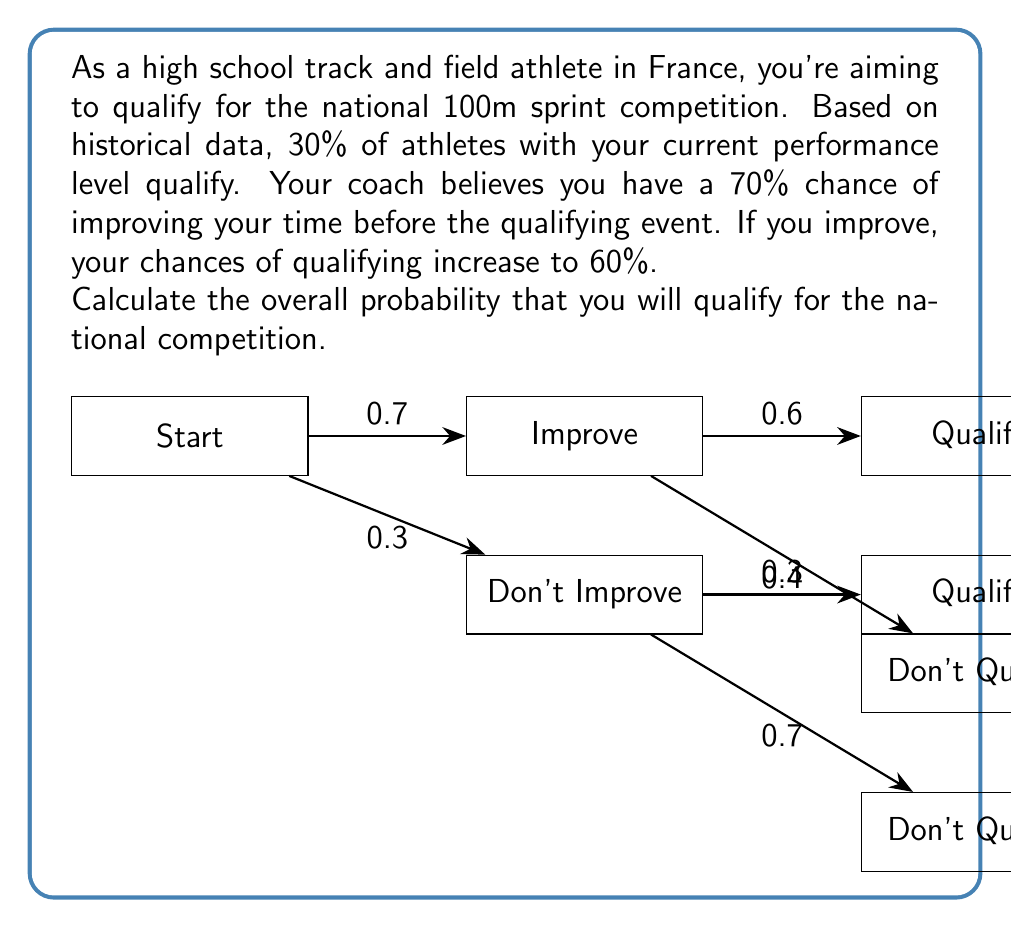Can you answer this question? Let's approach this problem using the law of total probability and Bayes' theorem:

1) Define events:
   A: Qualify for the national competition
   B: Improve your time

2) Given probabilities:
   P(B) = 0.7 (probability of improving)
   P(A|B) = 0.6 (probability of qualifying if improved)
   P(A|not B) = 0.3 (probability of qualifying if not improved)

3) Calculate P(A) using the law of total probability:
   $P(A) = P(A|B) \cdot P(B) + P(A|\text{not }B) \cdot P(\text{not }B)$

4) Calculate P(not B):
   $P(\text{not }B) = 1 - P(B) = 1 - 0.7 = 0.3$

5) Substitute values into the formula:
   $P(A) = 0.6 \cdot 0.7 + 0.3 \cdot 0.3$

6) Calculate:
   $P(A) = 0.42 + 0.09 = 0.51$

Therefore, the overall probability of qualifying for the national competition is 0.51 or 51%.
Answer: 0.51 